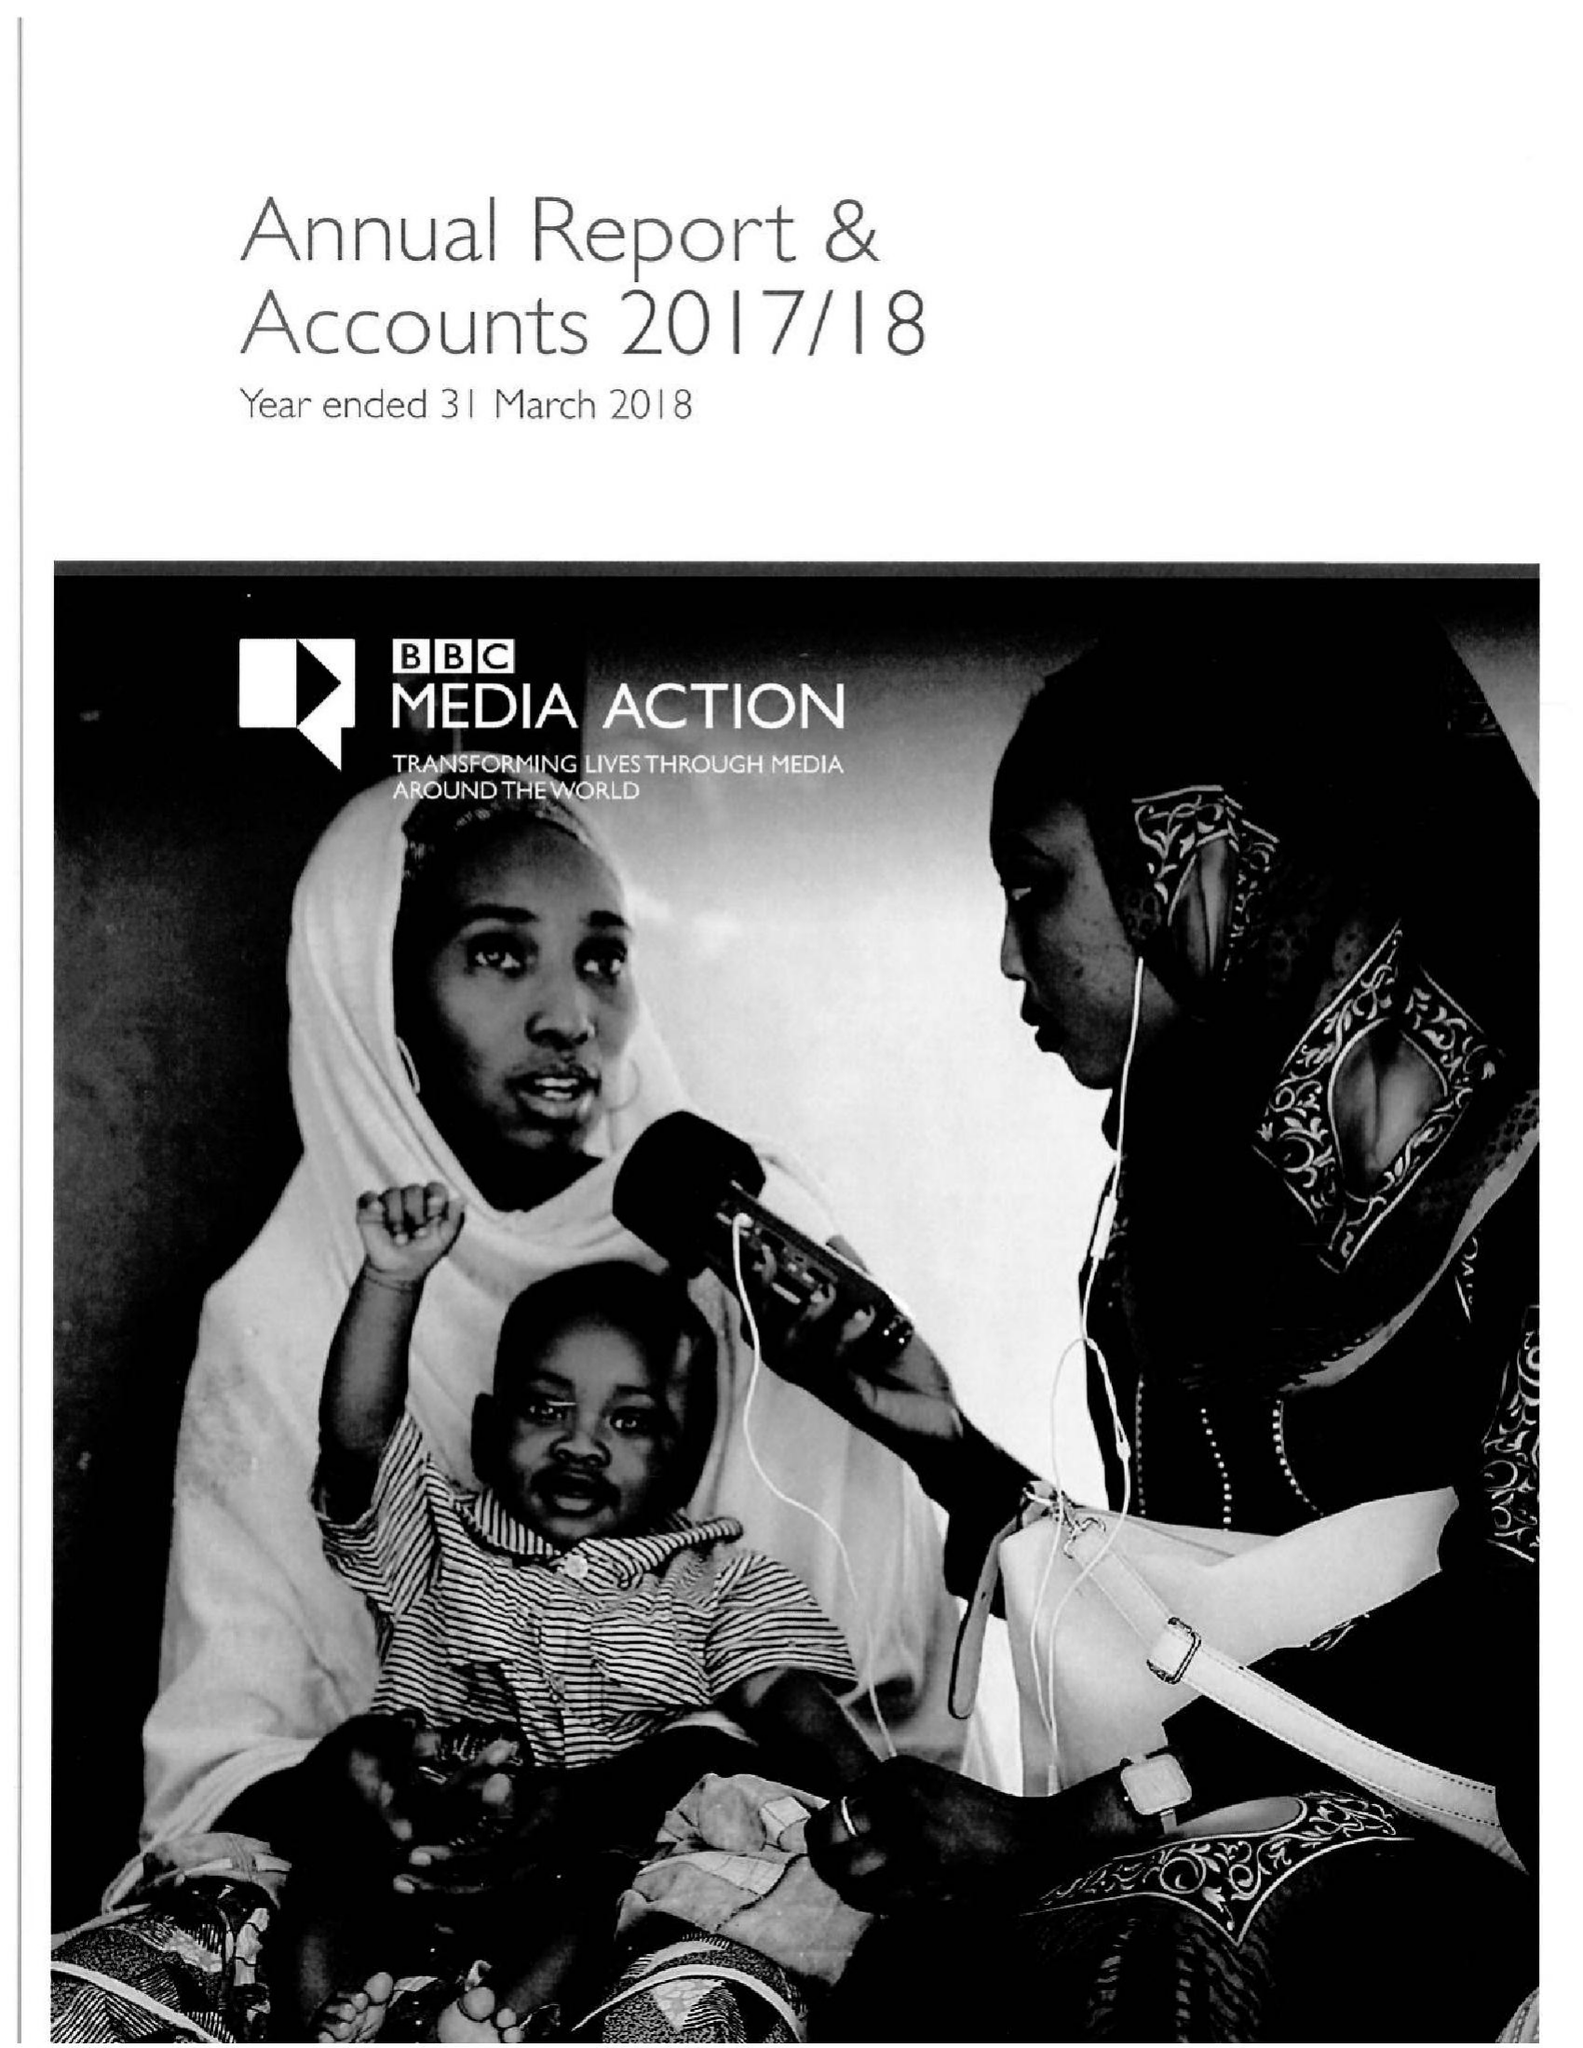What is the value for the charity_name?
Answer the question using a single word or phrase. Bbc Media Action 